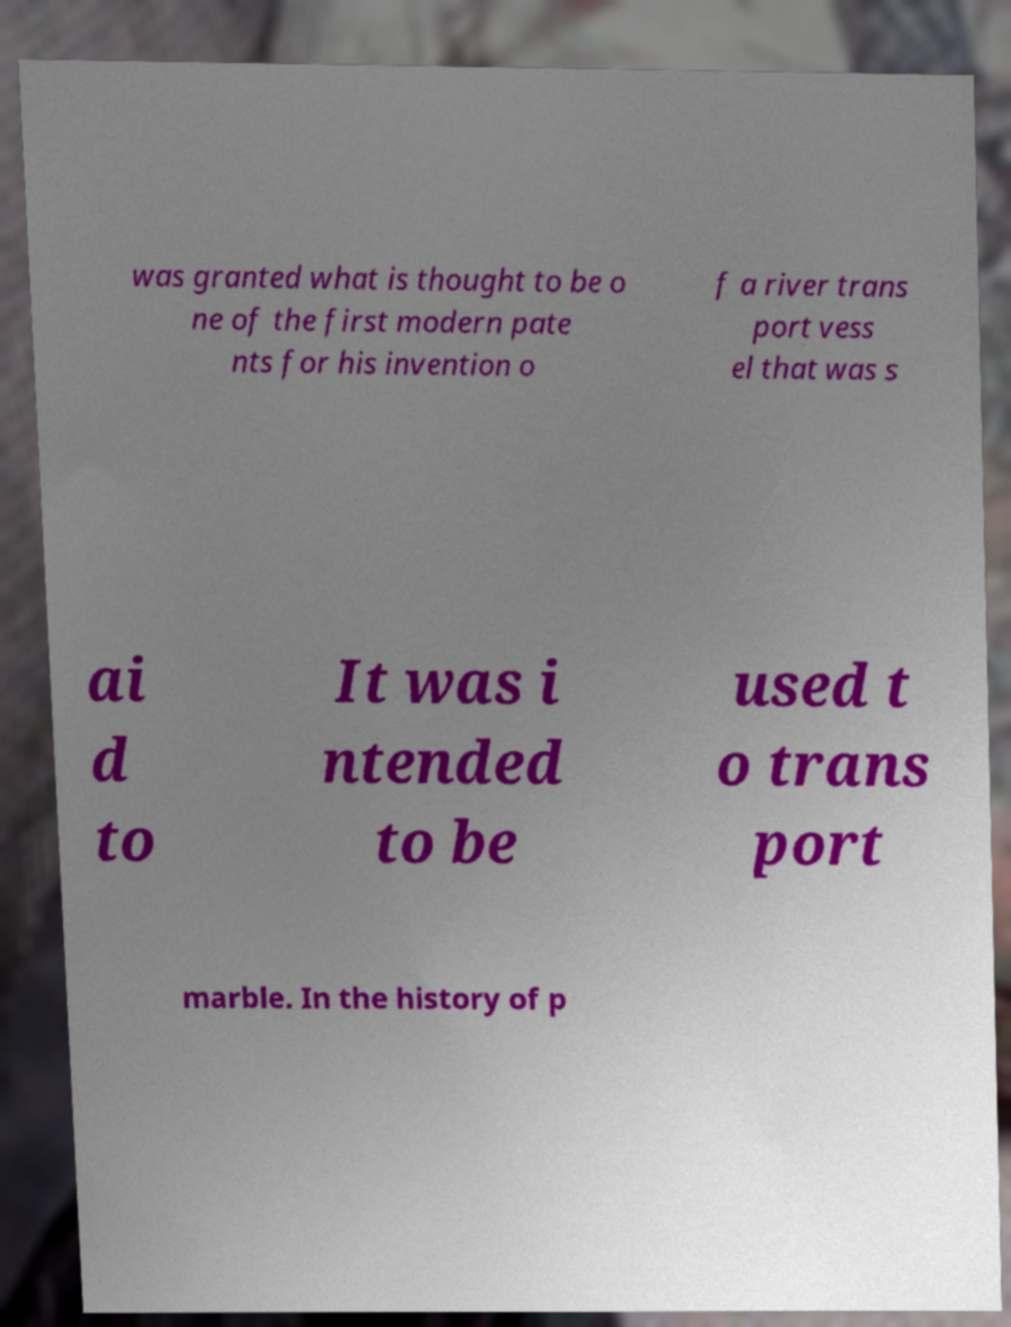Please read and relay the text visible in this image. What does it say? was granted what is thought to be o ne of the first modern pate nts for his invention o f a river trans port vess el that was s ai d to It was i ntended to be used t o trans port marble. In the history of p 